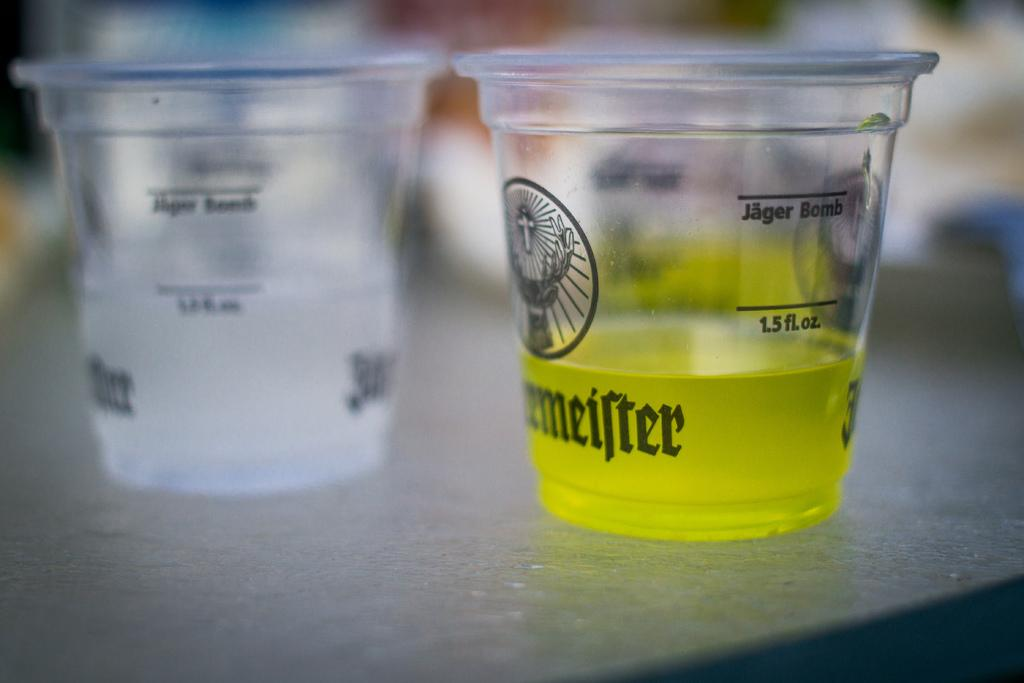<image>
Describe the image concisely. Two different drinks poured in shot glasses, filled less then 1.5 fl oz. 